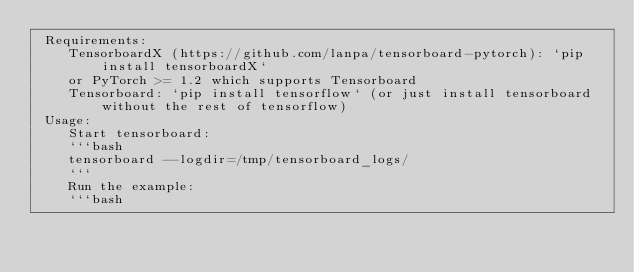Convert code to text. <code><loc_0><loc_0><loc_500><loc_500><_Python_> Requirements:
    TensorboardX (https://github.com/lanpa/tensorboard-pytorch): `pip install tensorboardX`
    or PyTorch >= 1.2 which supports Tensorboard
    Tensorboard: `pip install tensorflow` (or just install tensorboard without the rest of tensorflow)
 Usage:
    Start tensorboard:
    ```bash
    tensorboard --logdir=/tmp/tensorboard_logs/
    ```
    Run the example:
    ```bash</code> 